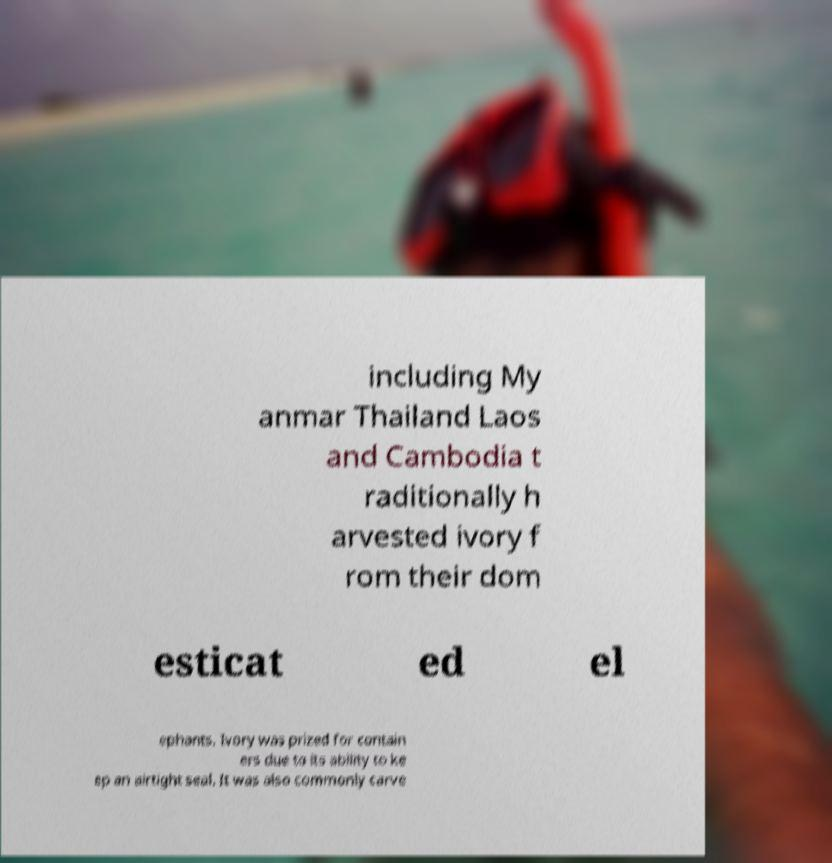There's text embedded in this image that I need extracted. Can you transcribe it verbatim? including My anmar Thailand Laos and Cambodia t raditionally h arvested ivory f rom their dom esticat ed el ephants. Ivory was prized for contain ers due to its ability to ke ep an airtight seal. It was also commonly carve 